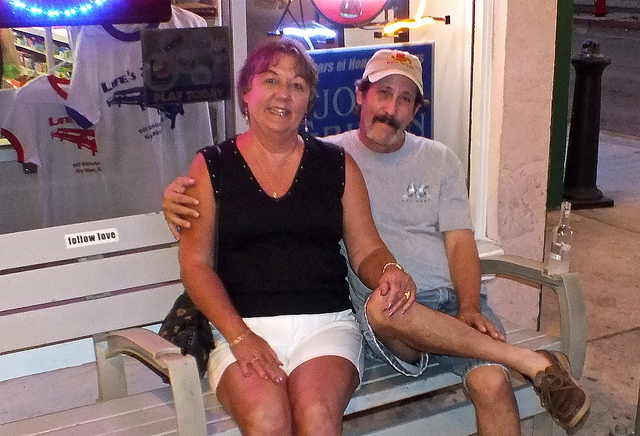<image>What does it say on the beach photo? I don't know exactly what it says on the beach as it can be 'life', 'follow love' or 'nothing'. What does it say on the beach photo? I am not sure what does it say on the beach photo. It can be seen "life's", "follow love" or "nothing". 